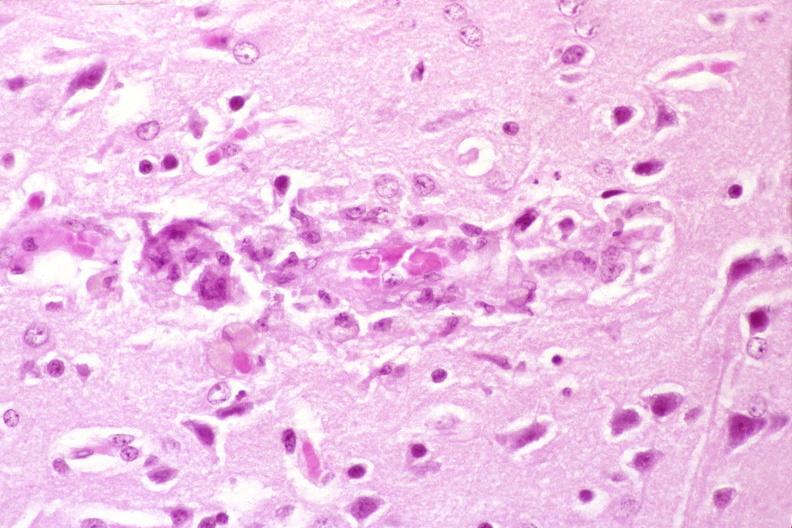does cortical nodule show brain, hiv neuropathy, microglial nodule with giant cell?
Answer the question using a single word or phrase. No 